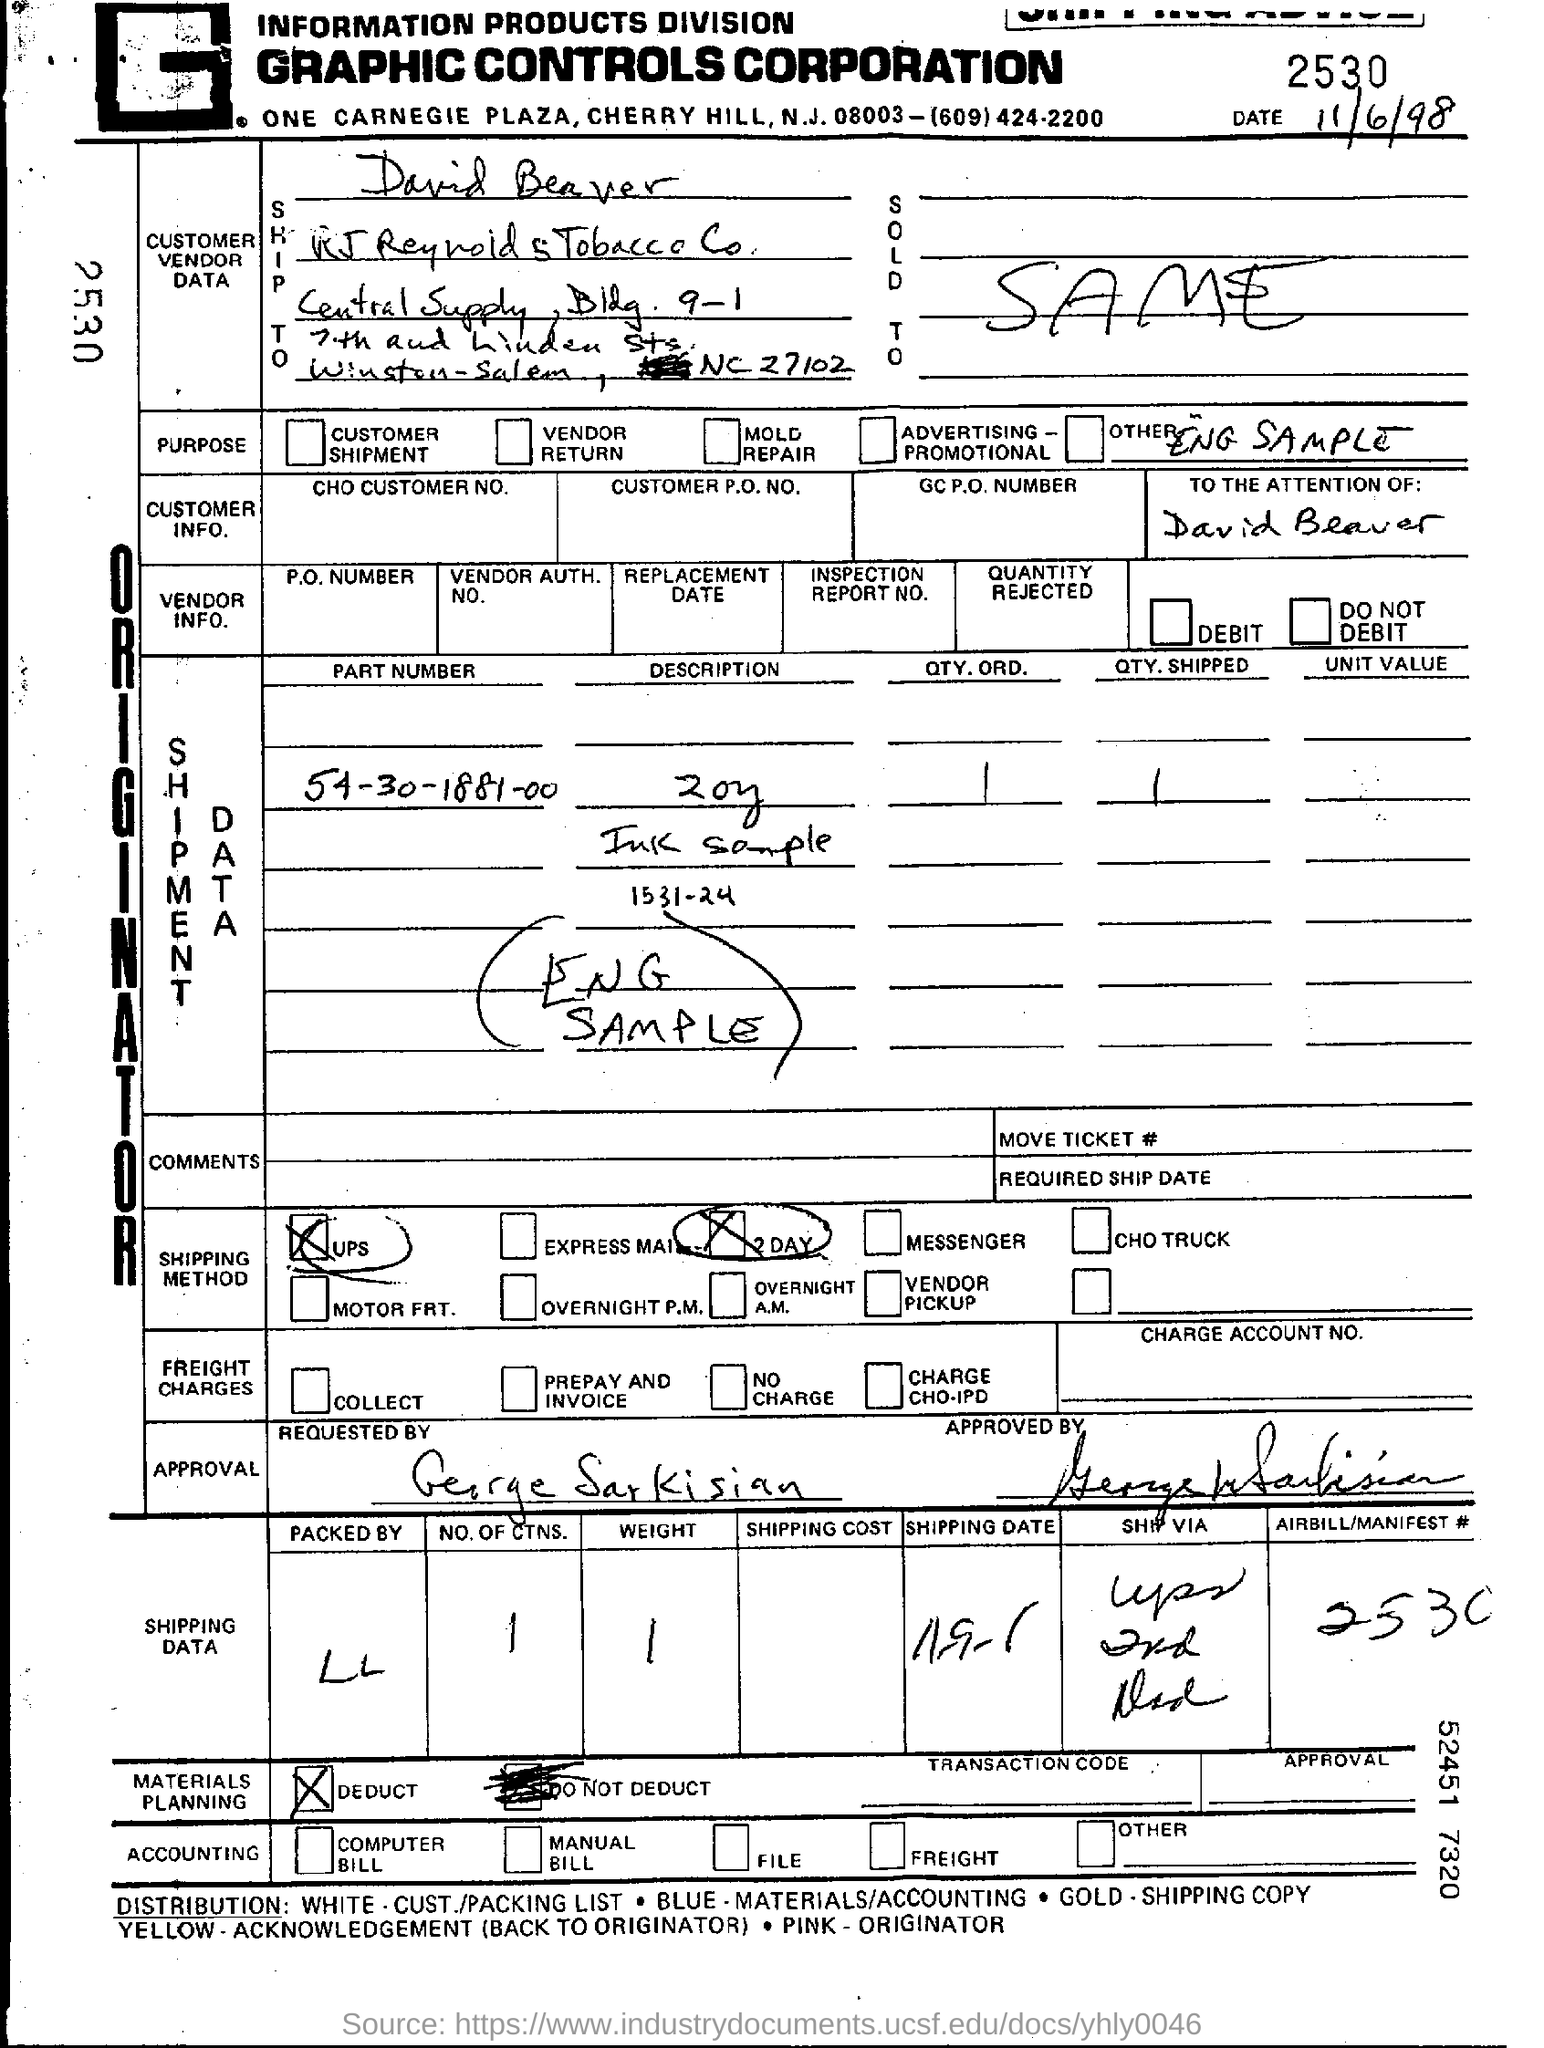Outline some significant characteristics in this image. The date mentioned in this document is November 6, 1998. 